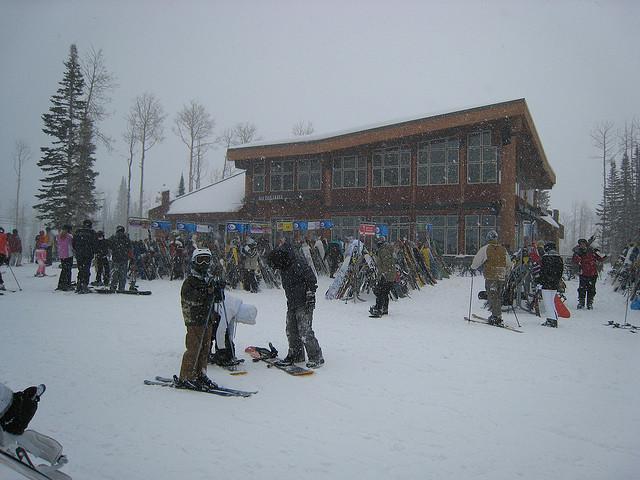How many people are there?
Give a very brief answer. 4. How many sandwiches are visible in the photo?
Give a very brief answer. 0. 